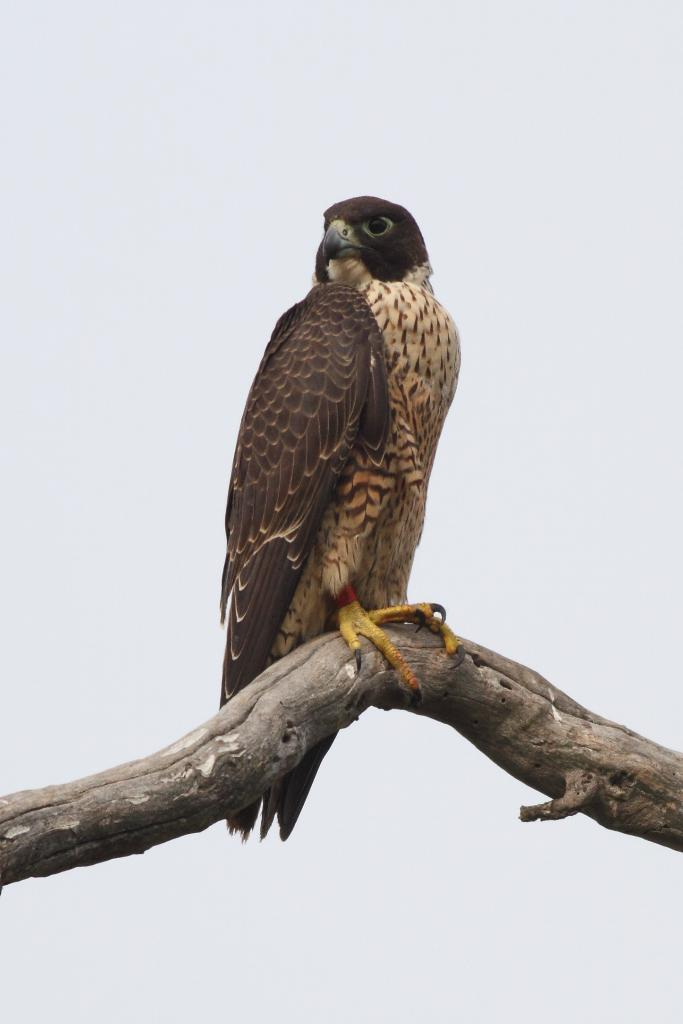Where was the picture taken? The picture was taken outside. What animal can be seen in the image? There is an eagle in the image. What is the eagle standing on? The eagle is standing on a branch of a tree. What can be seen in the background of the image? There is a sky visible in the background of the image. What type of example can be seen in the image? There is no example present in the image; it features an eagle standing on a tree branch. What acoustics can be heard in the image? The image is a still photograph, so there are no sounds or acoustics present. 